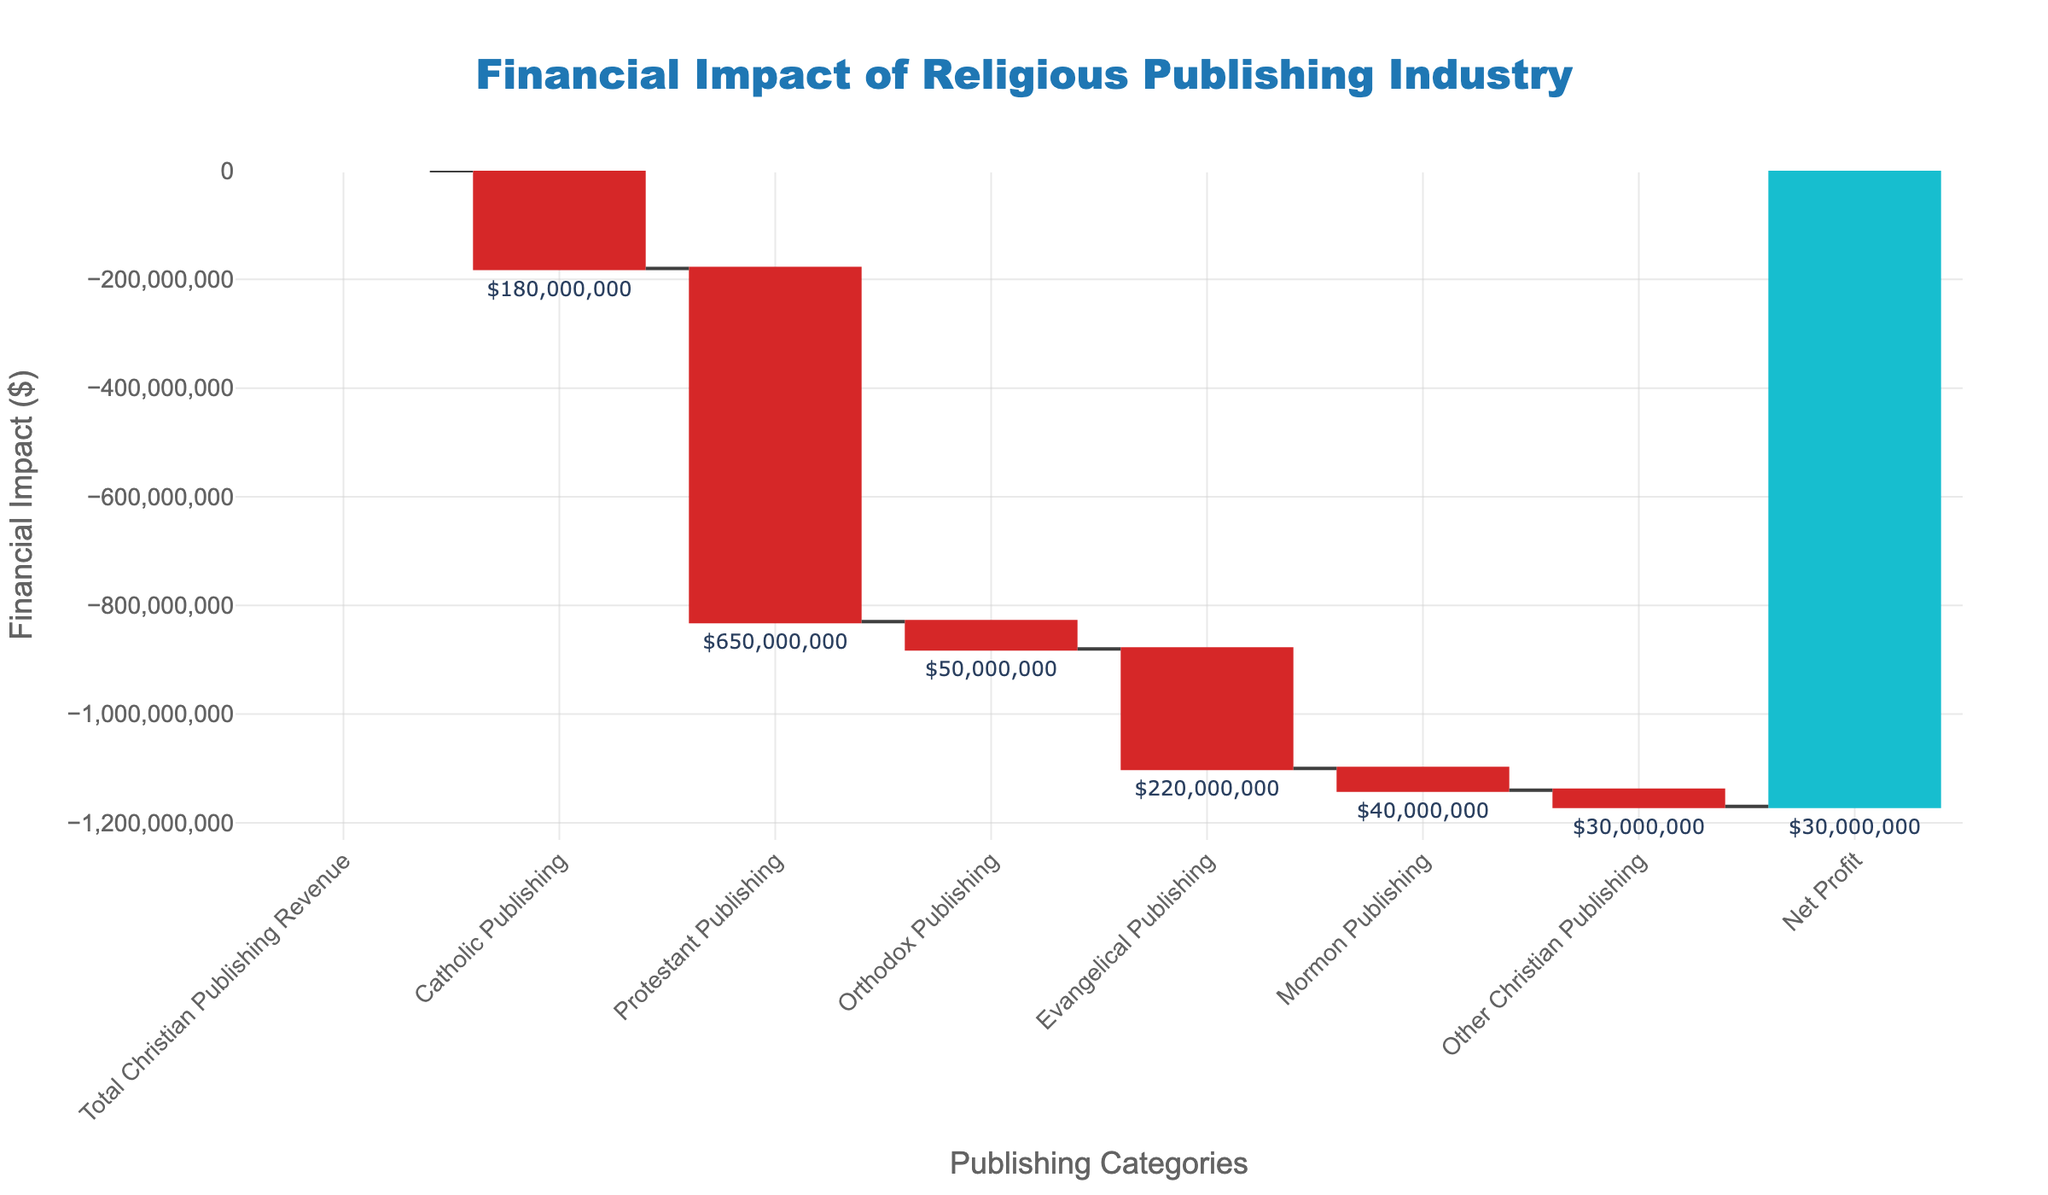What is the total revenue of the Christian publishing industry? The figure shows "Total Christian Publishing Revenue" as the first bar in the chart, with the corresponding value labeled.
Answer: $1,200,000,000 What is the financial impact of Catholic publishing on the total revenue? The chart shows the "Catholic Publishing" bar in red (indicating a decrease), with the value next to it indicating a negative impact.
Answer: -$180,000,000 How much profit does the Christian publishing industry generate after all expenses? The last bar labeled "Net Profit" shows the financial outcome after accounting for all categories, indicated at the top of the chart.
Answer: $30,000,000 Which category has the largest negative financial impact? By observing the height and labels of each segment, "Protestant Publishing" shows the largest negative value.
Answer: Protestant Publishing What is the combined financial impact of Orthodox and Mormon publishing? Add the values of "Orthodox Publishing" and "Mormon Publishing" shown on the bars: -$50,000,000 + -$40,000,000.
Answer: -$90,000,000 How does the financial impact of Evangelical publishing compare to that of Catholic publishing? Compare the heights and values of the "Evangelical Publishing" and "Catholic Publishing" bars. Evangelical publishing has a higher negative value than Catholic publishing.
Answer: Evangelical publishing has a greater negative impact What is the net change in revenue due to the Protestant and Evangelical publishing categories combined? Sum the negative impacts of "Protestant Publishing" and "Evangelical Publishing": -$650,000,000 (Protestant) + -$220,000,000 (Evangelical).
Answer: -$870,000,000 How much higher is the total Christian publishing revenue compared to the net profit? Subtract the value of "Net Profit" from "Total Christian Publishing Revenue": $1,200,000,000 - $30,000,000.
Answer: $1,170,000,000 What is the financial contribution of other Christian publishing categories? The "Other Christian Publishing" category is shown with a negative impact next to its bar on the chart.
Answer: -$30,000,000 How many categories contribute to revenue loss in the Christian publishing industry? Count the categories represented by red bars indicating negative impacts: Catholic, Protestant, Orthodox, Evangelical, Mormon, and Other Christian Publishing.
Answer: 6 categories 